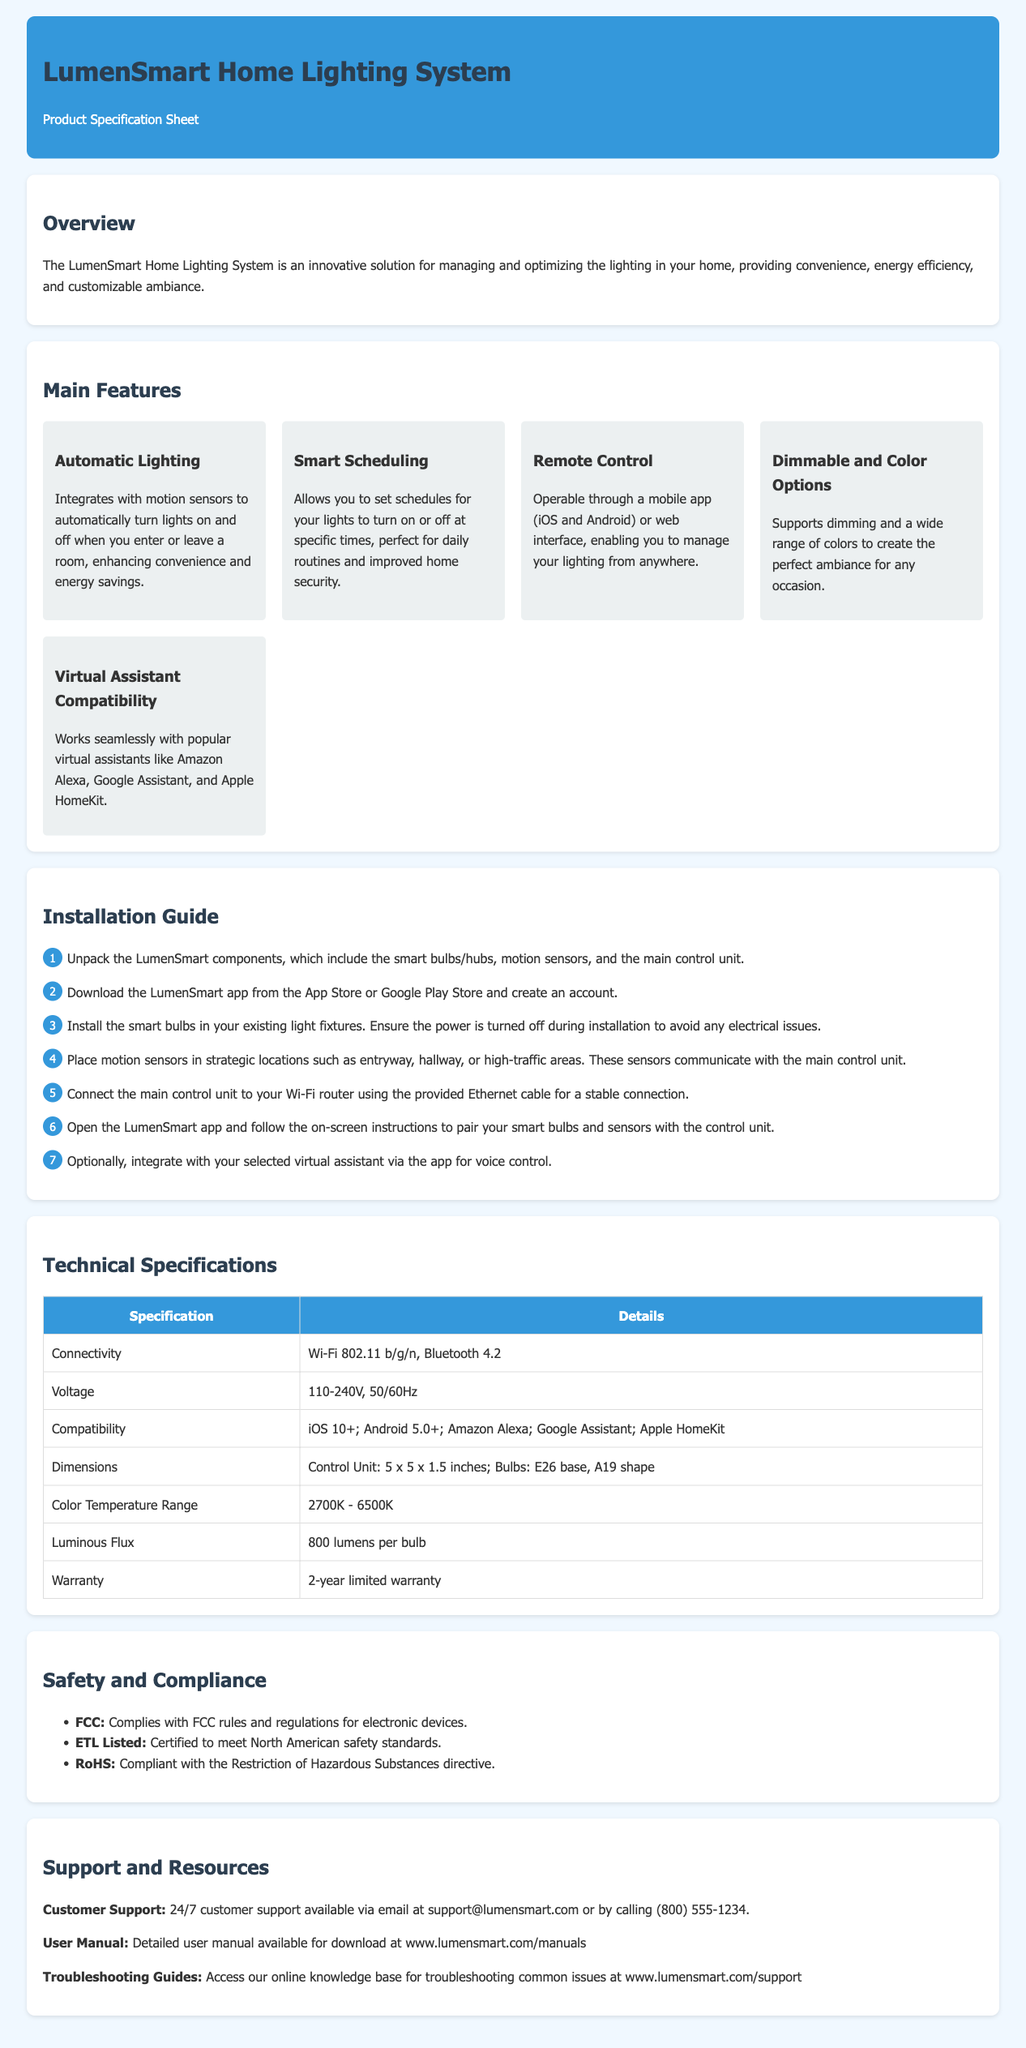what is the name of the product? The product name is found in the header section of the document.
Answer: LumenSmart Home Lighting System how many main features are listed? The number of main features can be counted in the "Main Features" section.
Answer: Five what is the color temperature range? The color temperature range can be found in the "Technical Specifications" table.
Answer: 2700K - 6500K what is the warranty period? The warranty period is stated in the "Technical Specifications" section.
Answer: 2-year limited warranty which virtual assistants is the system compatible with? Compatibility with virtual assistants is listed in the "Main Features" section.
Answer: Amazon Alexa, Google Assistant, Apple HomeKit what is the first step in the installation guide? The first step in the "Installation Guide" section indicates how to start the installation.
Answer: Unpack the LumenSmart components what is the main purpose of the LumenSmart system? The main purpose is described in the "Overview" section of the document.
Answer: Managing and optimizing the lighting how can users control their lights remotely? The method for remote control is explained in the "Main Features" section.
Answer: Mobile app or web interface where can users access troubleshooting guides? The location for troubleshooting guides is mentioned in the "Support and Resources" section.
Answer: www.lumensmart.com/support 